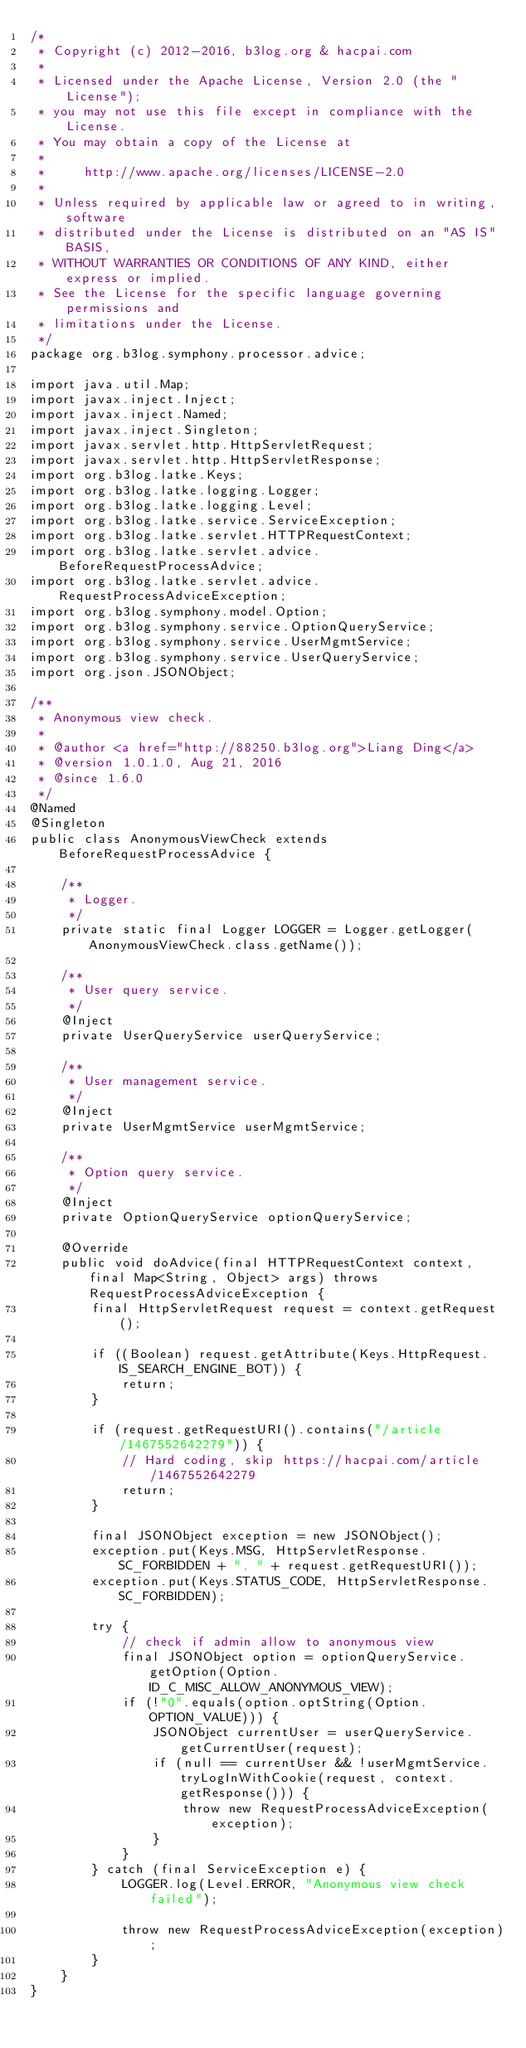Convert code to text. <code><loc_0><loc_0><loc_500><loc_500><_Java_>/*
 * Copyright (c) 2012-2016, b3log.org & hacpai.com
 *
 * Licensed under the Apache License, Version 2.0 (the "License");
 * you may not use this file except in compliance with the License.
 * You may obtain a copy of the License at
 *
 *     http://www.apache.org/licenses/LICENSE-2.0
 *
 * Unless required by applicable law or agreed to in writing, software
 * distributed under the License is distributed on an "AS IS" BASIS,
 * WITHOUT WARRANTIES OR CONDITIONS OF ANY KIND, either express or implied.
 * See the License for the specific language governing permissions and
 * limitations under the License.
 */
package org.b3log.symphony.processor.advice;

import java.util.Map;
import javax.inject.Inject;
import javax.inject.Named;
import javax.inject.Singleton;
import javax.servlet.http.HttpServletRequest;
import javax.servlet.http.HttpServletResponse;
import org.b3log.latke.Keys;
import org.b3log.latke.logging.Logger;
import org.b3log.latke.logging.Level;
import org.b3log.latke.service.ServiceException;
import org.b3log.latke.servlet.HTTPRequestContext;
import org.b3log.latke.servlet.advice.BeforeRequestProcessAdvice;
import org.b3log.latke.servlet.advice.RequestProcessAdviceException;
import org.b3log.symphony.model.Option;
import org.b3log.symphony.service.OptionQueryService;
import org.b3log.symphony.service.UserMgmtService;
import org.b3log.symphony.service.UserQueryService;
import org.json.JSONObject;

/**
 * Anonymous view check.
 *
 * @author <a href="http://88250.b3log.org">Liang Ding</a>
 * @version 1.0.1.0, Aug 21, 2016
 * @since 1.6.0
 */
@Named
@Singleton
public class AnonymousViewCheck extends BeforeRequestProcessAdvice {

    /**
     * Logger.
     */
    private static final Logger LOGGER = Logger.getLogger(AnonymousViewCheck.class.getName());

    /**
     * User query service.
     */
    @Inject
    private UserQueryService userQueryService;

    /**
     * User management service.
     */
    @Inject
    private UserMgmtService userMgmtService;

    /**
     * Option query service.
     */
    @Inject
    private OptionQueryService optionQueryService;

    @Override
    public void doAdvice(final HTTPRequestContext context, final Map<String, Object> args) throws RequestProcessAdviceException {
        final HttpServletRequest request = context.getRequest();

        if ((Boolean) request.getAttribute(Keys.HttpRequest.IS_SEARCH_ENGINE_BOT)) {
            return;
        }

        if (request.getRequestURI().contains("/article/1467552642279")) {
            // Hard coding, skip https://hacpai.com/article/1467552642279
            return;
        }

        final JSONObject exception = new JSONObject();
        exception.put(Keys.MSG, HttpServletResponse.SC_FORBIDDEN + ", " + request.getRequestURI());
        exception.put(Keys.STATUS_CODE, HttpServletResponse.SC_FORBIDDEN);

        try {
            // check if admin allow to anonymous view
            final JSONObject option = optionQueryService.getOption(Option.ID_C_MISC_ALLOW_ANONYMOUS_VIEW);
            if (!"0".equals(option.optString(Option.OPTION_VALUE))) {
                JSONObject currentUser = userQueryService.getCurrentUser(request);
                if (null == currentUser && !userMgmtService.tryLogInWithCookie(request, context.getResponse())) {
                    throw new RequestProcessAdviceException(exception);
                }
            }
        } catch (final ServiceException e) {
            LOGGER.log(Level.ERROR, "Anonymous view check failed");

            throw new RequestProcessAdviceException(exception);
        }
    }
}
</code> 